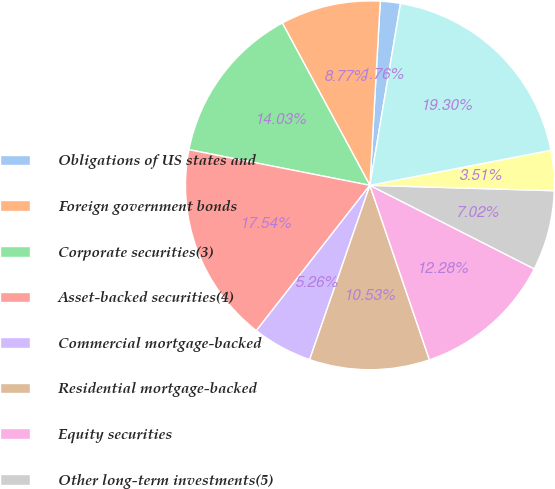<chart> <loc_0><loc_0><loc_500><loc_500><pie_chart><fcel>Obligations of US states and<fcel>Foreign government bonds<fcel>Corporate securities(3)<fcel>Asset-backed securities(4)<fcel>Commercial mortgage-backed<fcel>Residential mortgage-backed<fcel>Equity securities<fcel>Other long-term investments(5)<fcel>Other assets<fcel>Subtotal excluding separate<nl><fcel>1.76%<fcel>8.77%<fcel>14.03%<fcel>17.54%<fcel>5.26%<fcel>10.53%<fcel>12.28%<fcel>7.02%<fcel>3.51%<fcel>19.3%<nl></chart> 